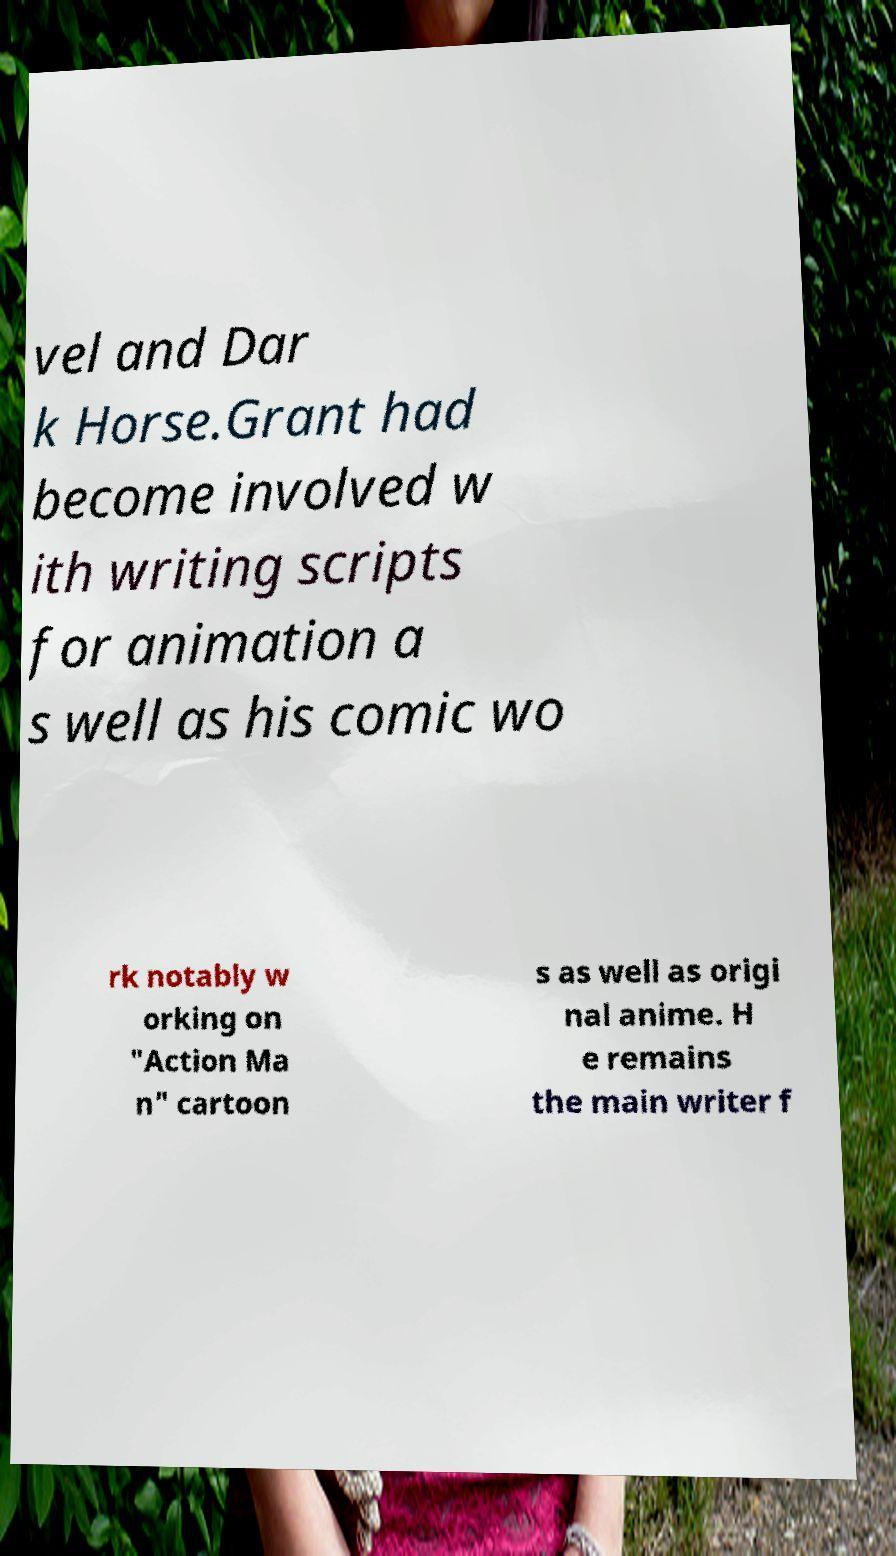For documentation purposes, I need the text within this image transcribed. Could you provide that? vel and Dar k Horse.Grant had become involved w ith writing scripts for animation a s well as his comic wo rk notably w orking on "Action Ma n" cartoon s as well as origi nal anime. H e remains the main writer f 